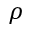Convert formula to latex. <formula><loc_0><loc_0><loc_500><loc_500>\rho</formula> 